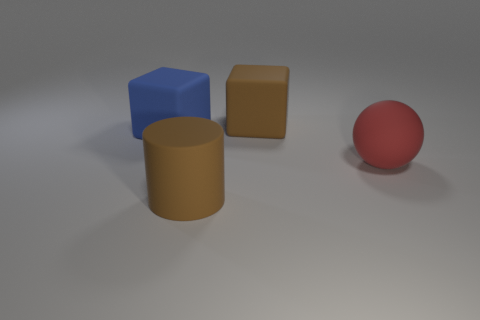Add 1 matte cylinders. How many objects exist? 5 Subtract all cylinders. How many objects are left? 3 Subtract all small matte balls. Subtract all big brown rubber things. How many objects are left? 2 Add 4 big brown cubes. How many big brown cubes are left? 5 Add 3 cyan objects. How many cyan objects exist? 3 Subtract 0 gray cylinders. How many objects are left? 4 